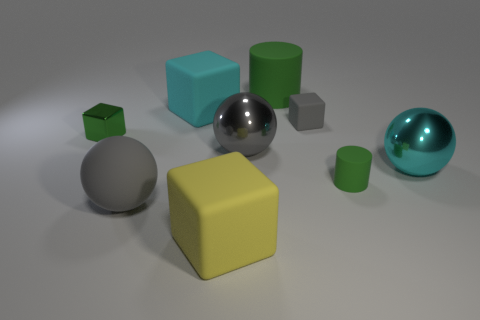How many large objects are yellow things or cyan cubes?
Your answer should be very brief. 2. How many cyan metallic objects are behind the large cyan sphere?
Give a very brief answer. 0. Are there any objects that have the same color as the big matte ball?
Offer a very short reply. Yes. There is a gray metallic object that is the same size as the gray rubber sphere; what is its shape?
Give a very brief answer. Sphere. What number of green things are balls or large metal things?
Give a very brief answer. 0. How many rubber cubes have the same size as the gray rubber ball?
Make the answer very short. 2. There is a small object that is the same color as the matte ball; what shape is it?
Provide a short and direct response. Cube. How many objects are either yellow rubber cylinders or matte things that are in front of the big gray rubber object?
Keep it short and to the point. 1. There is a metallic object that is on the left side of the big yellow rubber object; does it have the same size as the green matte object in front of the small metal block?
Provide a short and direct response. Yes. What number of big gray matte things have the same shape as the tiny shiny object?
Ensure brevity in your answer.  0. 